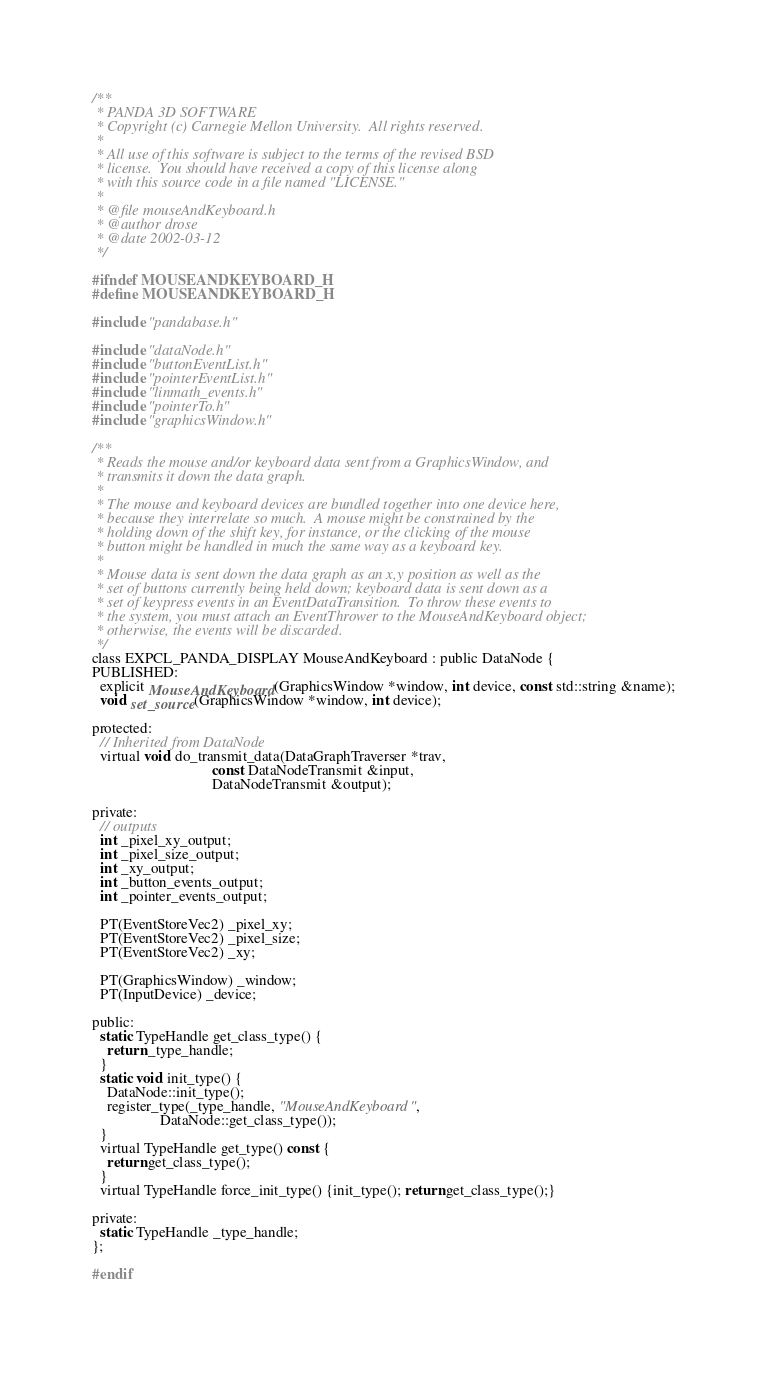Convert code to text. <code><loc_0><loc_0><loc_500><loc_500><_C_>/**
 * PANDA 3D SOFTWARE
 * Copyright (c) Carnegie Mellon University.  All rights reserved.
 *
 * All use of this software is subject to the terms of the revised BSD
 * license.  You should have received a copy of this license along
 * with this source code in a file named "LICENSE."
 *
 * @file mouseAndKeyboard.h
 * @author drose
 * @date 2002-03-12
 */

#ifndef MOUSEANDKEYBOARD_H
#define MOUSEANDKEYBOARD_H

#include "pandabase.h"

#include "dataNode.h"
#include "buttonEventList.h"
#include "pointerEventList.h"
#include "linmath_events.h"
#include "pointerTo.h"
#include "graphicsWindow.h"

/**
 * Reads the mouse and/or keyboard data sent from a GraphicsWindow, and
 * transmits it down the data graph.
 *
 * The mouse and keyboard devices are bundled together into one device here,
 * because they interrelate so much.  A mouse might be constrained by the
 * holding down of the shift key, for instance, or the clicking of the mouse
 * button might be handled in much the same way as a keyboard key.
 *
 * Mouse data is sent down the data graph as an x,y position as well as the
 * set of buttons currently being held down; keyboard data is sent down as a
 * set of keypress events in an EventDataTransition.  To throw these events to
 * the system, you must attach an EventThrower to the MouseAndKeyboard object;
 * otherwise, the events will be discarded.
 */
class EXPCL_PANDA_DISPLAY MouseAndKeyboard : public DataNode {
PUBLISHED:
  explicit MouseAndKeyboard(GraphicsWindow *window, int device, const std::string &name);
  void set_source(GraphicsWindow *window, int device);

protected:
  // Inherited from DataNode
  virtual void do_transmit_data(DataGraphTraverser *trav,
                                const DataNodeTransmit &input,
                                DataNodeTransmit &output);

private:
  // outputs
  int _pixel_xy_output;
  int _pixel_size_output;
  int _xy_output;
  int _button_events_output;
  int _pointer_events_output;

  PT(EventStoreVec2) _pixel_xy;
  PT(EventStoreVec2) _pixel_size;
  PT(EventStoreVec2) _xy;

  PT(GraphicsWindow) _window;
  PT(InputDevice) _device;

public:
  static TypeHandle get_class_type() {
    return _type_handle;
  }
  static void init_type() {
    DataNode::init_type();
    register_type(_type_handle, "MouseAndKeyboard",
                  DataNode::get_class_type());
  }
  virtual TypeHandle get_type() const {
    return get_class_type();
  }
  virtual TypeHandle force_init_type() {init_type(); return get_class_type();}

private:
  static TypeHandle _type_handle;
};

#endif
</code> 